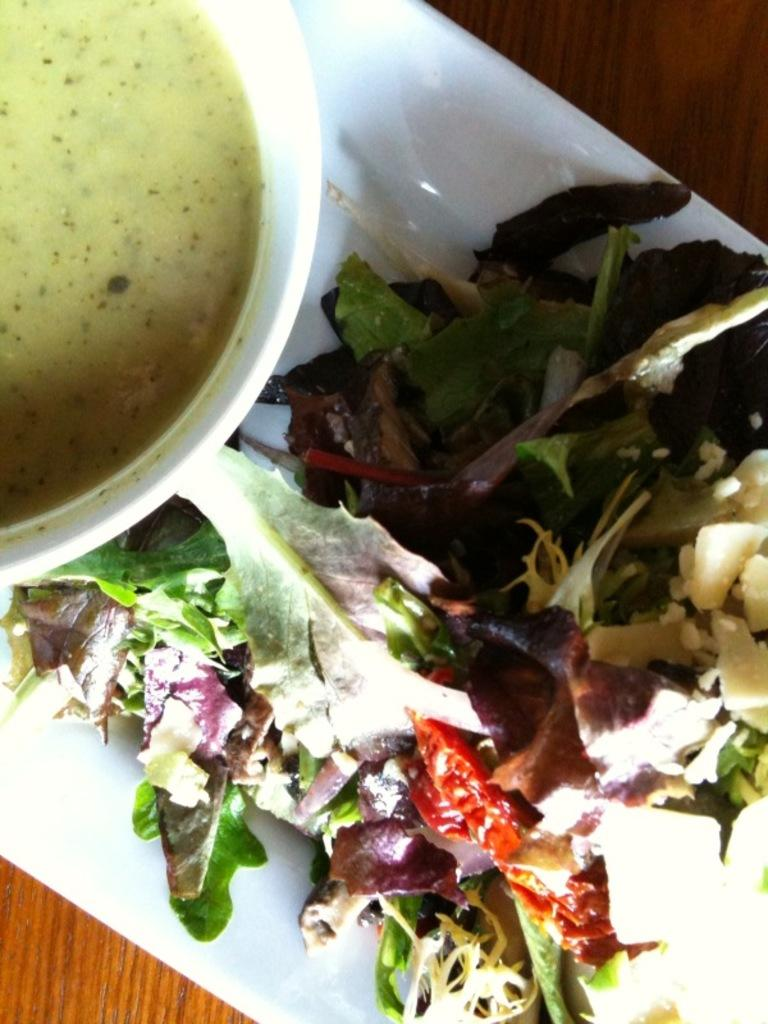What is on the wooden surface in the image? There is a white tray on the wooden surface. What can be found on the white tray? There is a bowl with a food item and a salad with leaves and other items on the tray. What type of canvas is used to create the sleet effect in the image? There is no canvas or sleet effect present in the image; it features a white tray with a bowl and a salad. Can you describe the taste of the food items in the image? The image does not provide information about the taste of the food items; it only shows their appearance. 